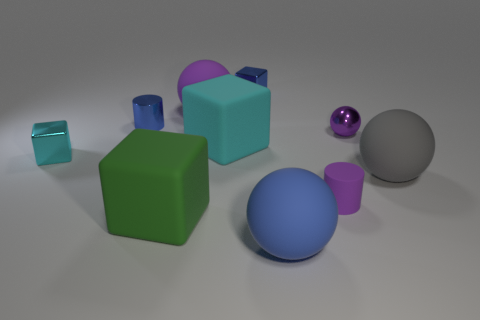Subtract 1 blocks. How many blocks are left? 3 Subtract all brown cubes. Subtract all cyan spheres. How many cubes are left? 4 Subtract all blocks. How many objects are left? 6 Subtract all big gray rubber blocks. Subtract all balls. How many objects are left? 6 Add 9 blue shiny blocks. How many blue shiny blocks are left? 10 Add 7 large cyan things. How many large cyan things exist? 8 Subtract 0 yellow balls. How many objects are left? 10 